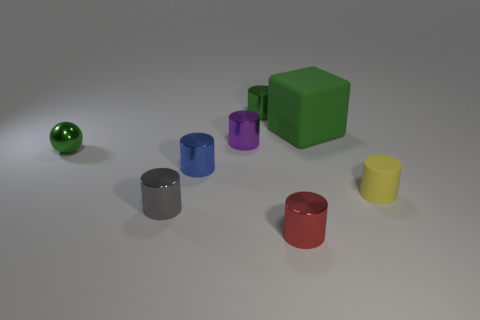Is the color of the matte cube the same as the sphere?
Ensure brevity in your answer.  Yes. How many other shiny balls have the same color as the tiny sphere?
Provide a short and direct response. 0. There is a green thing that is to the right of the green thing behind the green rubber cube; what size is it?
Offer a terse response. Large. The yellow object is what shape?
Provide a succinct answer. Cylinder. What material is the green object in front of the green rubber cube?
Your response must be concise. Metal. What color is the rubber object behind the small metal object that is on the left side of the small shiny cylinder left of the small blue thing?
Give a very brief answer. Green. There is a shiny ball that is the same size as the blue shiny cylinder; what color is it?
Your response must be concise. Green. How many matte objects are brown cubes or tiny purple cylinders?
Your answer should be compact. 0. There is a big cube that is made of the same material as the tiny yellow thing; what color is it?
Provide a short and direct response. Green. What material is the small object behind the matte object that is left of the tiny rubber cylinder?
Give a very brief answer. Metal. 